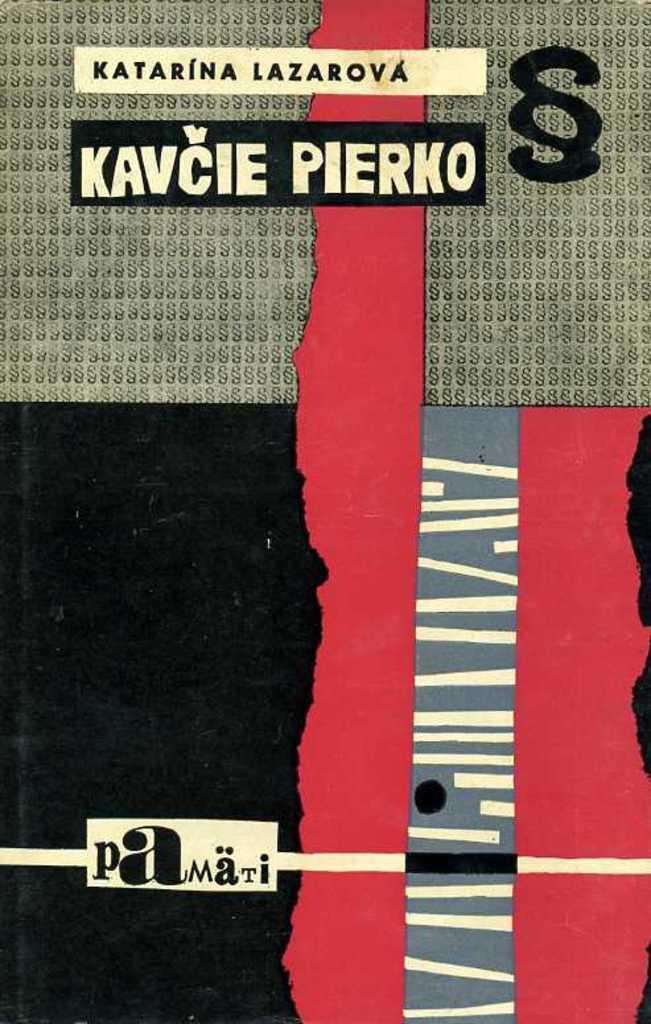Can you describe this image briefly? Here we can see a poster. On this poster we can see text written on it. 